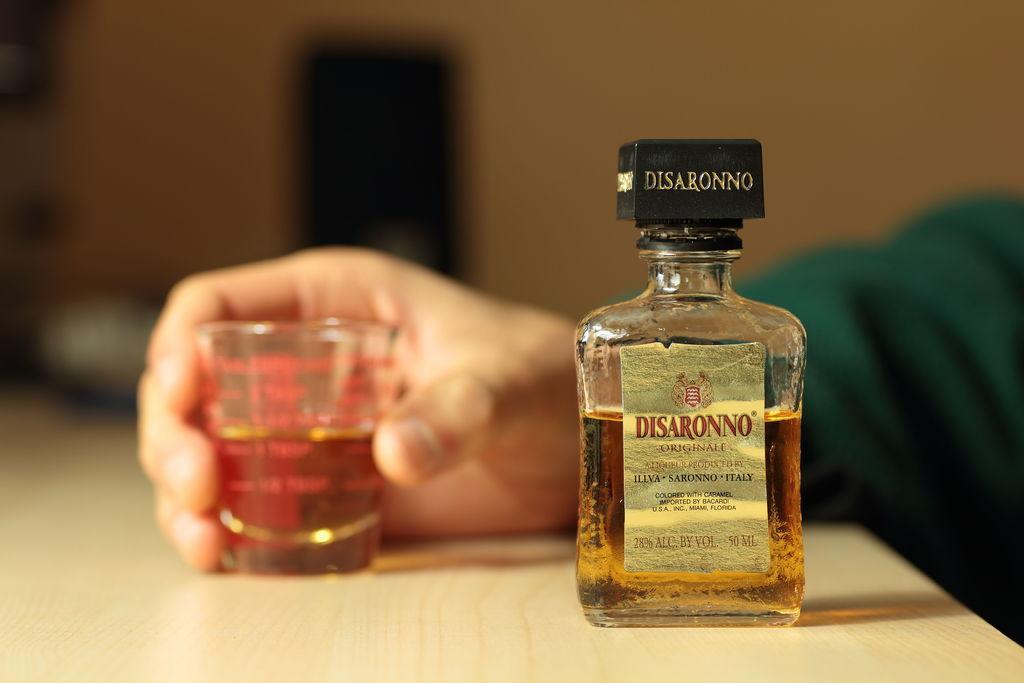How would you summarize this image in a sentence or two? In this image there is an alcohol bottle and a small glass. A man is holding the glass. the bottle and the glass are placed on a table. The background is blurry. 